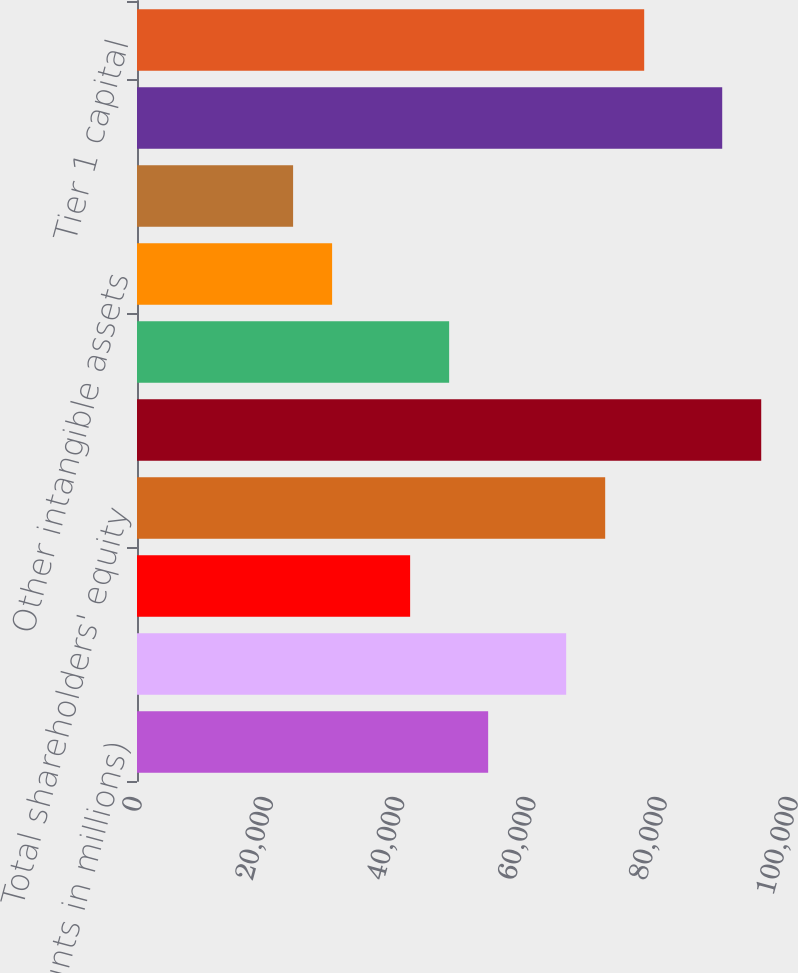<chart> <loc_0><loc_0><loc_500><loc_500><bar_chart><fcel>(dollar amounts in millions)<fcel>Common shareholders' equity<fcel>Preferred shareholders' equity<fcel>Total shareholders' equity<fcel>Total assets<fcel>Goodwill<fcel>Other intangible assets<fcel>Other intangible asset<fcel>Total tangible assets^(2)<fcel>Tier 1 capital<nl><fcel>53529.3<fcel>65422.8<fcel>41635.9<fcel>71369.5<fcel>95156.4<fcel>47582.6<fcel>29742.4<fcel>23795.7<fcel>89209.6<fcel>77316.2<nl></chart> 